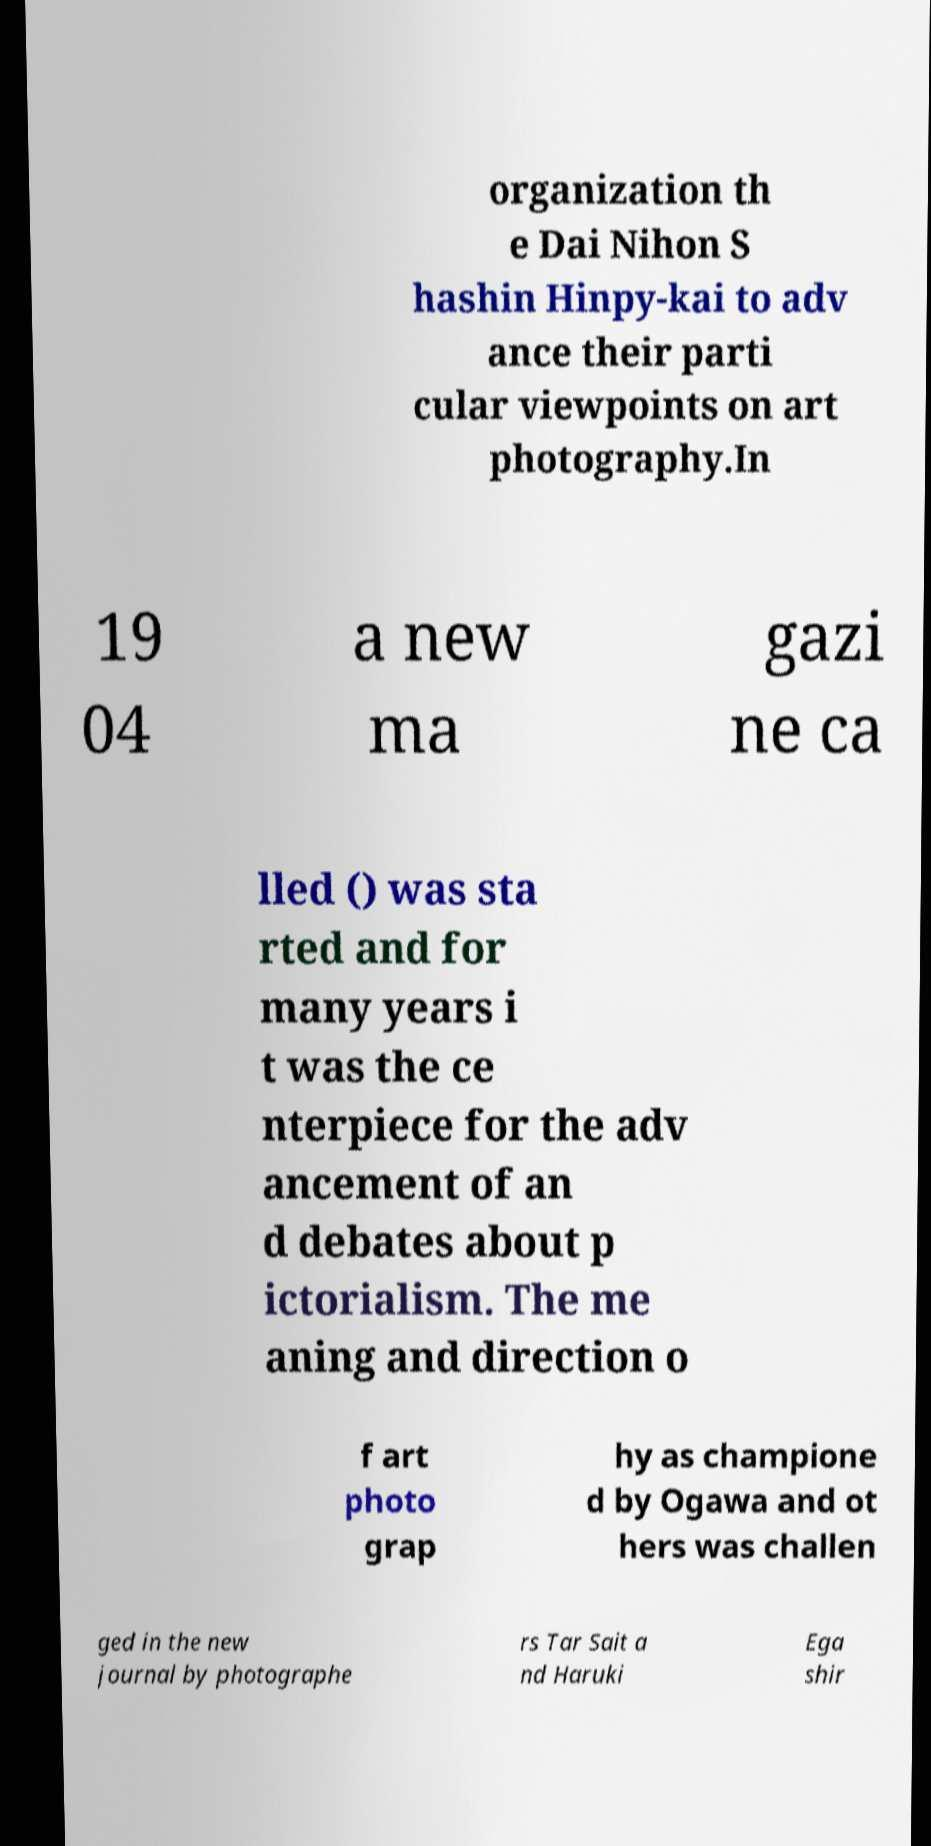Could you assist in decoding the text presented in this image and type it out clearly? organization th e Dai Nihon S hashin Hinpy-kai to adv ance their parti cular viewpoints on art photography.In 19 04 a new ma gazi ne ca lled () was sta rted and for many years i t was the ce nterpiece for the adv ancement of an d debates about p ictorialism. The me aning and direction o f art photo grap hy as champione d by Ogawa and ot hers was challen ged in the new journal by photographe rs Tar Sait a nd Haruki Ega shir 